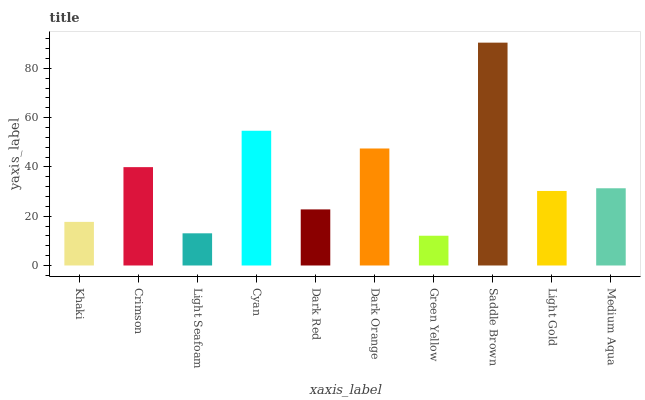Is Green Yellow the minimum?
Answer yes or no. Yes. Is Saddle Brown the maximum?
Answer yes or no. Yes. Is Crimson the minimum?
Answer yes or no. No. Is Crimson the maximum?
Answer yes or no. No. Is Crimson greater than Khaki?
Answer yes or no. Yes. Is Khaki less than Crimson?
Answer yes or no. Yes. Is Khaki greater than Crimson?
Answer yes or no. No. Is Crimson less than Khaki?
Answer yes or no. No. Is Medium Aqua the high median?
Answer yes or no. Yes. Is Light Gold the low median?
Answer yes or no. Yes. Is Green Yellow the high median?
Answer yes or no. No. Is Light Seafoam the low median?
Answer yes or no. No. 